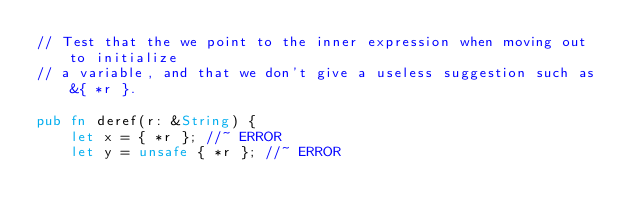Convert code to text. <code><loc_0><loc_0><loc_500><loc_500><_Rust_>// Test that the we point to the inner expression when moving out to initialize
// a variable, and that we don't give a useless suggestion such as &{ *r }.

pub fn deref(r: &String) {
    let x = { *r }; //~ ERROR
    let y = unsafe { *r }; //~ ERROR</code> 